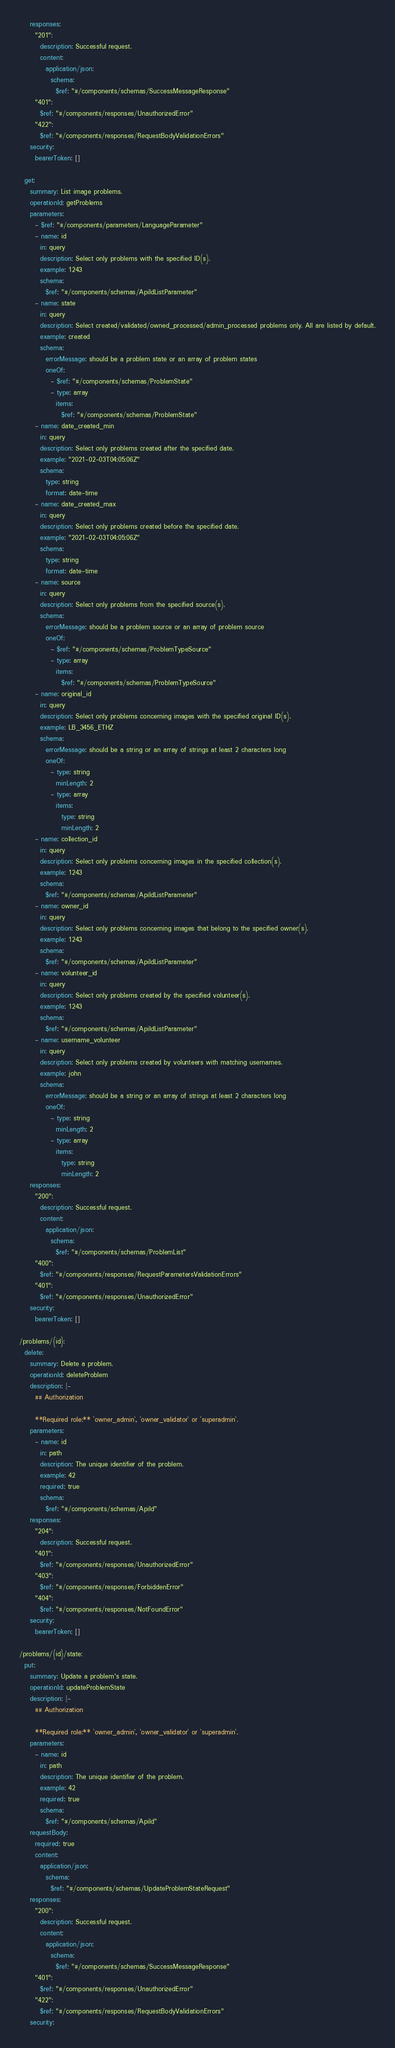<code> <loc_0><loc_0><loc_500><loc_500><_YAML_>    responses:
      "201":
        description: Successful request.
        content:
          application/json:
            schema:
              $ref: "#/components/schemas/SuccessMessageResponse"
      "401":
        $ref: "#/components/responses/UnauthorizedError"
      "422":
        $ref: "#/components/responses/RequestBodyValidationErrors"
    security:
      bearerToken: []

  get:
    summary: List image problems.
    operationId: getProblems
    parameters:
      - $ref: "#/components/parameters/LanguageParameter"
      - name: id
        in: query
        description: Select only problems with the specified ID(s).
        example: 1243
        schema:
          $ref: "#/components/schemas/ApiIdListParameter"
      - name: state
        in: query
        description: Select created/validated/owned_processed/admin_processed problems only. All are listed by default.
        example: created
        schema:
          errorMessage: should be a problem state or an array of problem states
          oneOf:
            - $ref: "#/components/schemas/ProblemState"
            - type: array
              items:
                $ref: "#/components/schemas/ProblemState"
      - name: date_created_min
        in: query
        description: Select only problems created after the specified date.
        example: "2021-02-03T04:05:06Z"
        schema:
          type: string
          format: date-time
      - name: date_created_max
        in: query
        description: Select only problems created before the specified date.
        example: "2021-02-03T04:05:06Z"
        schema:
          type: string
          format: date-time
      - name: source
        in: query
        description: Select only problems from the specified source(s).
        schema:
          errorMessage: should be a problem source or an array of problem source
          oneOf:
            - $ref: "#/components/schemas/ProblemTypeSource"
            - type: array
              items:
                $ref: "#/components/schemas/ProblemTypeSource"
      - name: original_id
        in: query
        description: Select only problems concerning images with the specified original ID(s).
        example: LB_3456_ETHZ
        schema:
          errorMessage: should be a string or an array of strings at least 2 characters long
          oneOf:
            - type: string
              minLength: 2
            - type: array
              items:
                type: string
                minLength: 2
      - name: collection_id
        in: query
        description: Select only problems concerning images in the specified collection(s).
        example: 1243
        schema:
          $ref: "#/components/schemas/ApiIdListParameter"
      - name: owner_id
        in: query
        description: Select only problems concerning images that belong to the specified owner(s).
        example: 1243
        schema:
          $ref: "#/components/schemas/ApiIdListParameter"
      - name: volunteer_id
        in: query
        description: Select only problems created by the specified volunteer(s).
        example: 1243
        schema:
          $ref: "#/components/schemas/ApiIdListParameter"
      - name: username_volunteer
        in: query
        description: Select only problems created by volunteers with matching usernames.
        example: john
        schema:
          errorMessage: should be a string or an array of strings at least 2 characters long
          oneOf:
            - type: string
              minLength: 2
            - type: array
              items:
                type: string
                minLength: 2
    responses:
      "200":
        description: Successful request.
        content:
          application/json:
            schema:
              $ref: "#/components/schemas/ProblemList"
      "400":
        $ref: "#/components/responses/RequestParametersValidationErrors"
      "401":
        $ref: "#/components/responses/UnauthorizedError"
    security:
      bearerToken: []

/problems/{id}:
  delete:
    summary: Delete a problem.
    operationId: deleteProblem
    description: |-
      ## Authorization

      **Required role:** `owner_admin`, `owner_validator` or `superadmin`.
    parameters:
      - name: id
        in: path
        description: The unique identifier of the problem.
        example: 42
        required: true
        schema:
          $ref: "#/components/schemas/ApiId"
    responses:
      "204":
        description: Successful request.
      "401":
        $ref: "#/components/responses/UnauthorizedError"
      "403":
        $ref: "#/components/responses/ForbiddenError"
      "404":
        $ref: "#/components/responses/NotFoundError"
    security:
      bearerToken: []

/problems/{id}/state:
  put:
    summary: Update a problem's state.
    operationId: updateProblemState
    description: |-
      ## Authorization

      **Required role:** `owner_admin`, `owner_validator` or `superadmin`.
    parameters:
      - name: id
        in: path
        description: The unique identifier of the problem.
        example: 42
        required: true
        schema:
          $ref: "#/components/schemas/ApiId"
    requestBody:
      required: true
      content:
        application/json:
          schema:
            $ref: "#/components/schemas/UpdateProblemStateRequest"
    responses:
      "200":
        description: Successful request.
        content:
          application/json:
            schema:
              $ref: "#/components/schemas/SuccessMessageResponse"
      "401":
        $ref: "#/components/responses/UnauthorizedError"
      "422":
        $ref: "#/components/responses/RequestBodyValidationErrors"
    security:</code> 